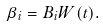Convert formula to latex. <formula><loc_0><loc_0><loc_500><loc_500>\beta _ { i } = B _ { i } W ( t ) .</formula> 